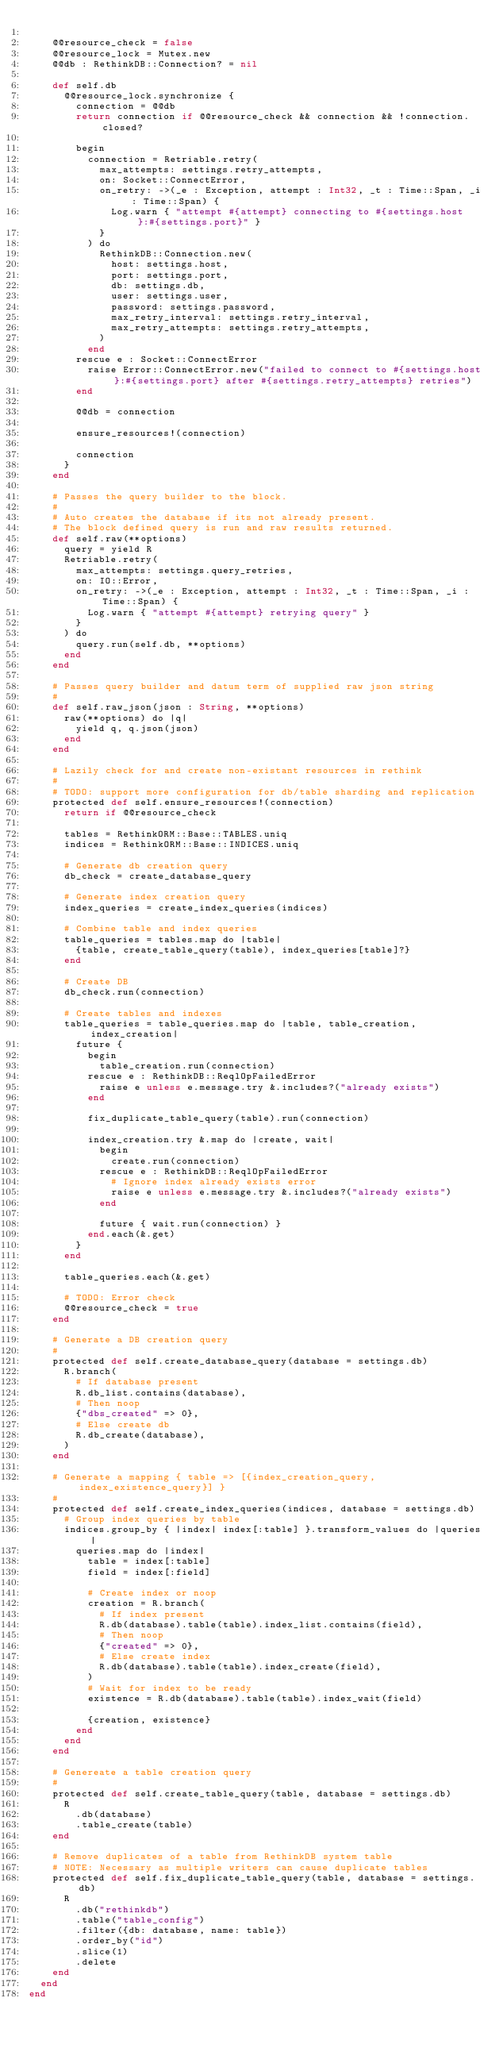<code> <loc_0><loc_0><loc_500><loc_500><_Crystal_>
    @@resource_check = false
    @@resource_lock = Mutex.new
    @@db : RethinkDB::Connection? = nil

    def self.db
      @@resource_lock.synchronize {
        connection = @@db
        return connection if @@resource_check && connection && !connection.closed?

        begin
          connection = Retriable.retry(
            max_attempts: settings.retry_attempts,
            on: Socket::ConnectError,
            on_retry: ->(_e : Exception, attempt : Int32, _t : Time::Span, _i : Time::Span) {
              Log.warn { "attempt #{attempt} connecting to #{settings.host}:#{settings.port}" }
            }
          ) do
            RethinkDB::Connection.new(
              host: settings.host,
              port: settings.port,
              db: settings.db,
              user: settings.user,
              password: settings.password,
              max_retry_interval: settings.retry_interval,
              max_retry_attempts: settings.retry_attempts,
            )
          end
        rescue e : Socket::ConnectError
          raise Error::ConnectError.new("failed to connect to #{settings.host}:#{settings.port} after #{settings.retry_attempts} retries")
        end

        @@db = connection

        ensure_resources!(connection)

        connection
      }
    end

    # Passes the query builder to the block.
    #
    # Auto creates the database if its not already present.
    # The block defined query is run and raw results returned.
    def self.raw(**options)
      query = yield R
      Retriable.retry(
        max_attempts: settings.query_retries,
        on: IO::Error,
        on_retry: ->(_e : Exception, attempt : Int32, _t : Time::Span, _i : Time::Span) {
          Log.warn { "attempt #{attempt} retrying query" }
        }
      ) do
        query.run(self.db, **options)
      end
    end

    # Passes query builder and datum term of supplied raw json string
    #
    def self.raw_json(json : String, **options)
      raw(**options) do |q|
        yield q, q.json(json)
      end
    end

    # Lazily check for and create non-existant resources in rethink
    #
    # TODO: support more configuration for db/table sharding and replication
    protected def self.ensure_resources!(connection)
      return if @@resource_check

      tables = RethinkORM::Base::TABLES.uniq
      indices = RethinkORM::Base::INDICES.uniq

      # Generate db creation query
      db_check = create_database_query

      # Generate index creation query
      index_queries = create_index_queries(indices)

      # Combine table and index queries
      table_queries = tables.map do |table|
        {table, create_table_query(table), index_queries[table]?}
      end

      # Create DB
      db_check.run(connection)

      # Create tables and indexes
      table_queries = table_queries.map do |table, table_creation, index_creation|
        future {
          begin
            table_creation.run(connection)
          rescue e : RethinkDB::ReqlOpFailedError
            raise e unless e.message.try &.includes?("already exists")
          end

          fix_duplicate_table_query(table).run(connection)

          index_creation.try &.map do |create, wait|
            begin
              create.run(connection)
            rescue e : RethinkDB::ReqlOpFailedError
              # Ignore index already exists error
              raise e unless e.message.try &.includes?("already exists")
            end

            future { wait.run(connection) }
          end.each(&.get)
        }
      end

      table_queries.each(&.get)

      # TODO: Error check
      @@resource_check = true
    end

    # Generate a DB creation query
    #
    protected def self.create_database_query(database = settings.db)
      R.branch(
        # If database present
        R.db_list.contains(database),
        # Then noop
        {"dbs_created" => 0},
        # Else create db
        R.db_create(database),
      )
    end

    # Generate a mapping { table => [{index_creation_query, index_existence_query}] }
    #
    protected def self.create_index_queries(indices, database = settings.db)
      # Group index queries by table
      indices.group_by { |index| index[:table] }.transform_values do |queries|
        queries.map do |index|
          table = index[:table]
          field = index[:field]

          # Create index or noop
          creation = R.branch(
            # If index present
            R.db(database).table(table).index_list.contains(field),
            # Then noop
            {"created" => 0},
            # Else create index
            R.db(database).table(table).index_create(field),
          )
          # Wait for index to be ready
          existence = R.db(database).table(table).index_wait(field)

          {creation, existence}
        end
      end
    end

    # Genereate a table creation query
    #
    protected def self.create_table_query(table, database = settings.db)
      R
        .db(database)
        .table_create(table)
    end

    # Remove duplicates of a table from RethinkDB system table
    # NOTE: Necessary as multiple writers can cause duplicate tables
    protected def self.fix_duplicate_table_query(table, database = settings.db)
      R
        .db("rethinkdb")
        .table("table_config")
        .filter({db: database, name: table})
        .order_by("id")
        .slice(1)
        .delete
    end
  end
end
</code> 